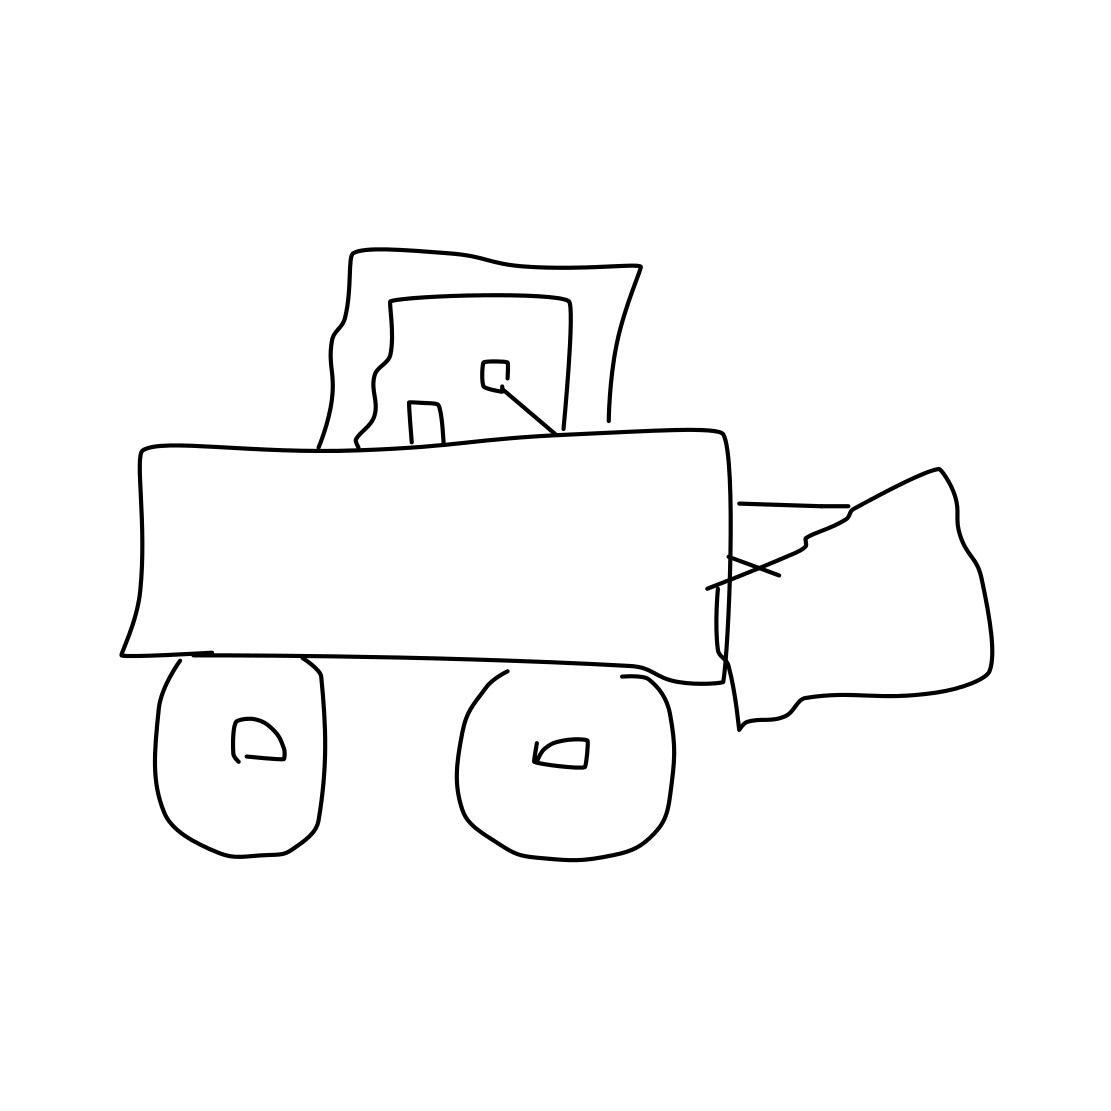Could you describe what is depicted in this image? The image shows a simplistic line drawing of a bulldozer. It features large wheels, a frontal blade which seems damaged, and a simple driver's cabin with minimal details. 